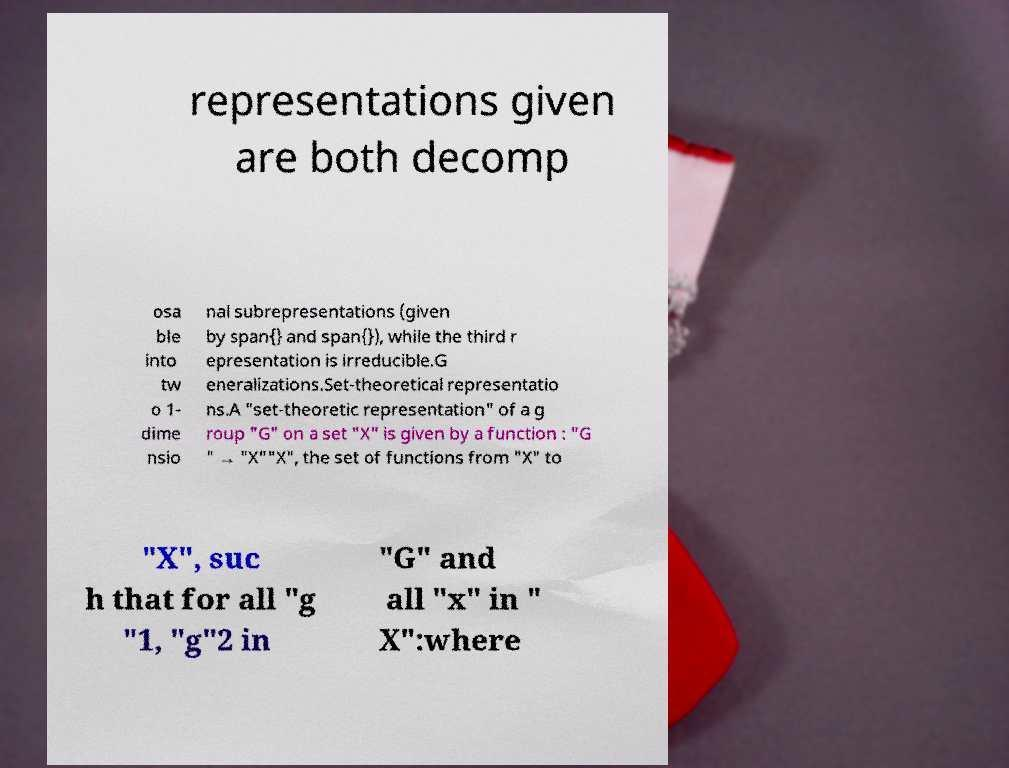Could you assist in decoding the text presented in this image and type it out clearly? representations given are both decomp osa ble into tw o 1- dime nsio nal subrepresentations (given by span{} and span{}), while the third r epresentation is irreducible.G eneralizations.Set-theoretical representatio ns.A "set-theoretic representation" of a g roup "G" on a set "X" is given by a function : "G " → "X""X", the set of functions from "X" to "X", suc h that for all "g "1, "g"2 in "G" and all "x" in " X":where 